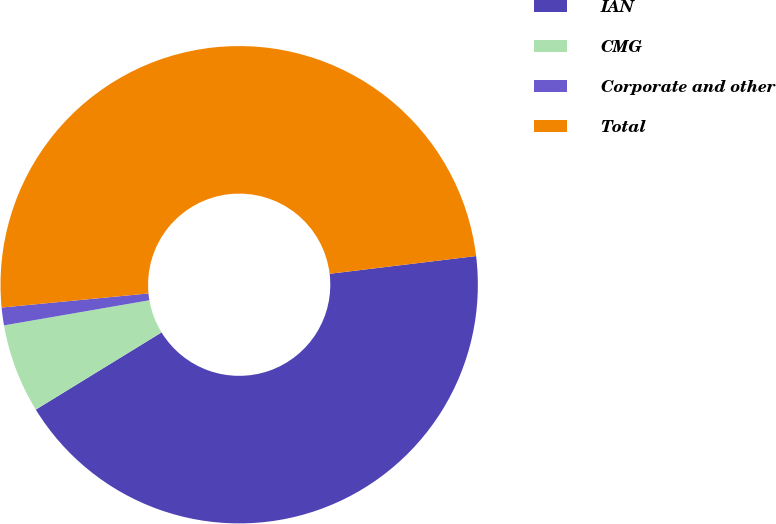Convert chart to OTSL. <chart><loc_0><loc_0><loc_500><loc_500><pie_chart><fcel>IAN<fcel>CMG<fcel>Corporate and other<fcel>Total<nl><fcel>43.15%<fcel>6.04%<fcel>1.2%<fcel>49.6%<nl></chart> 